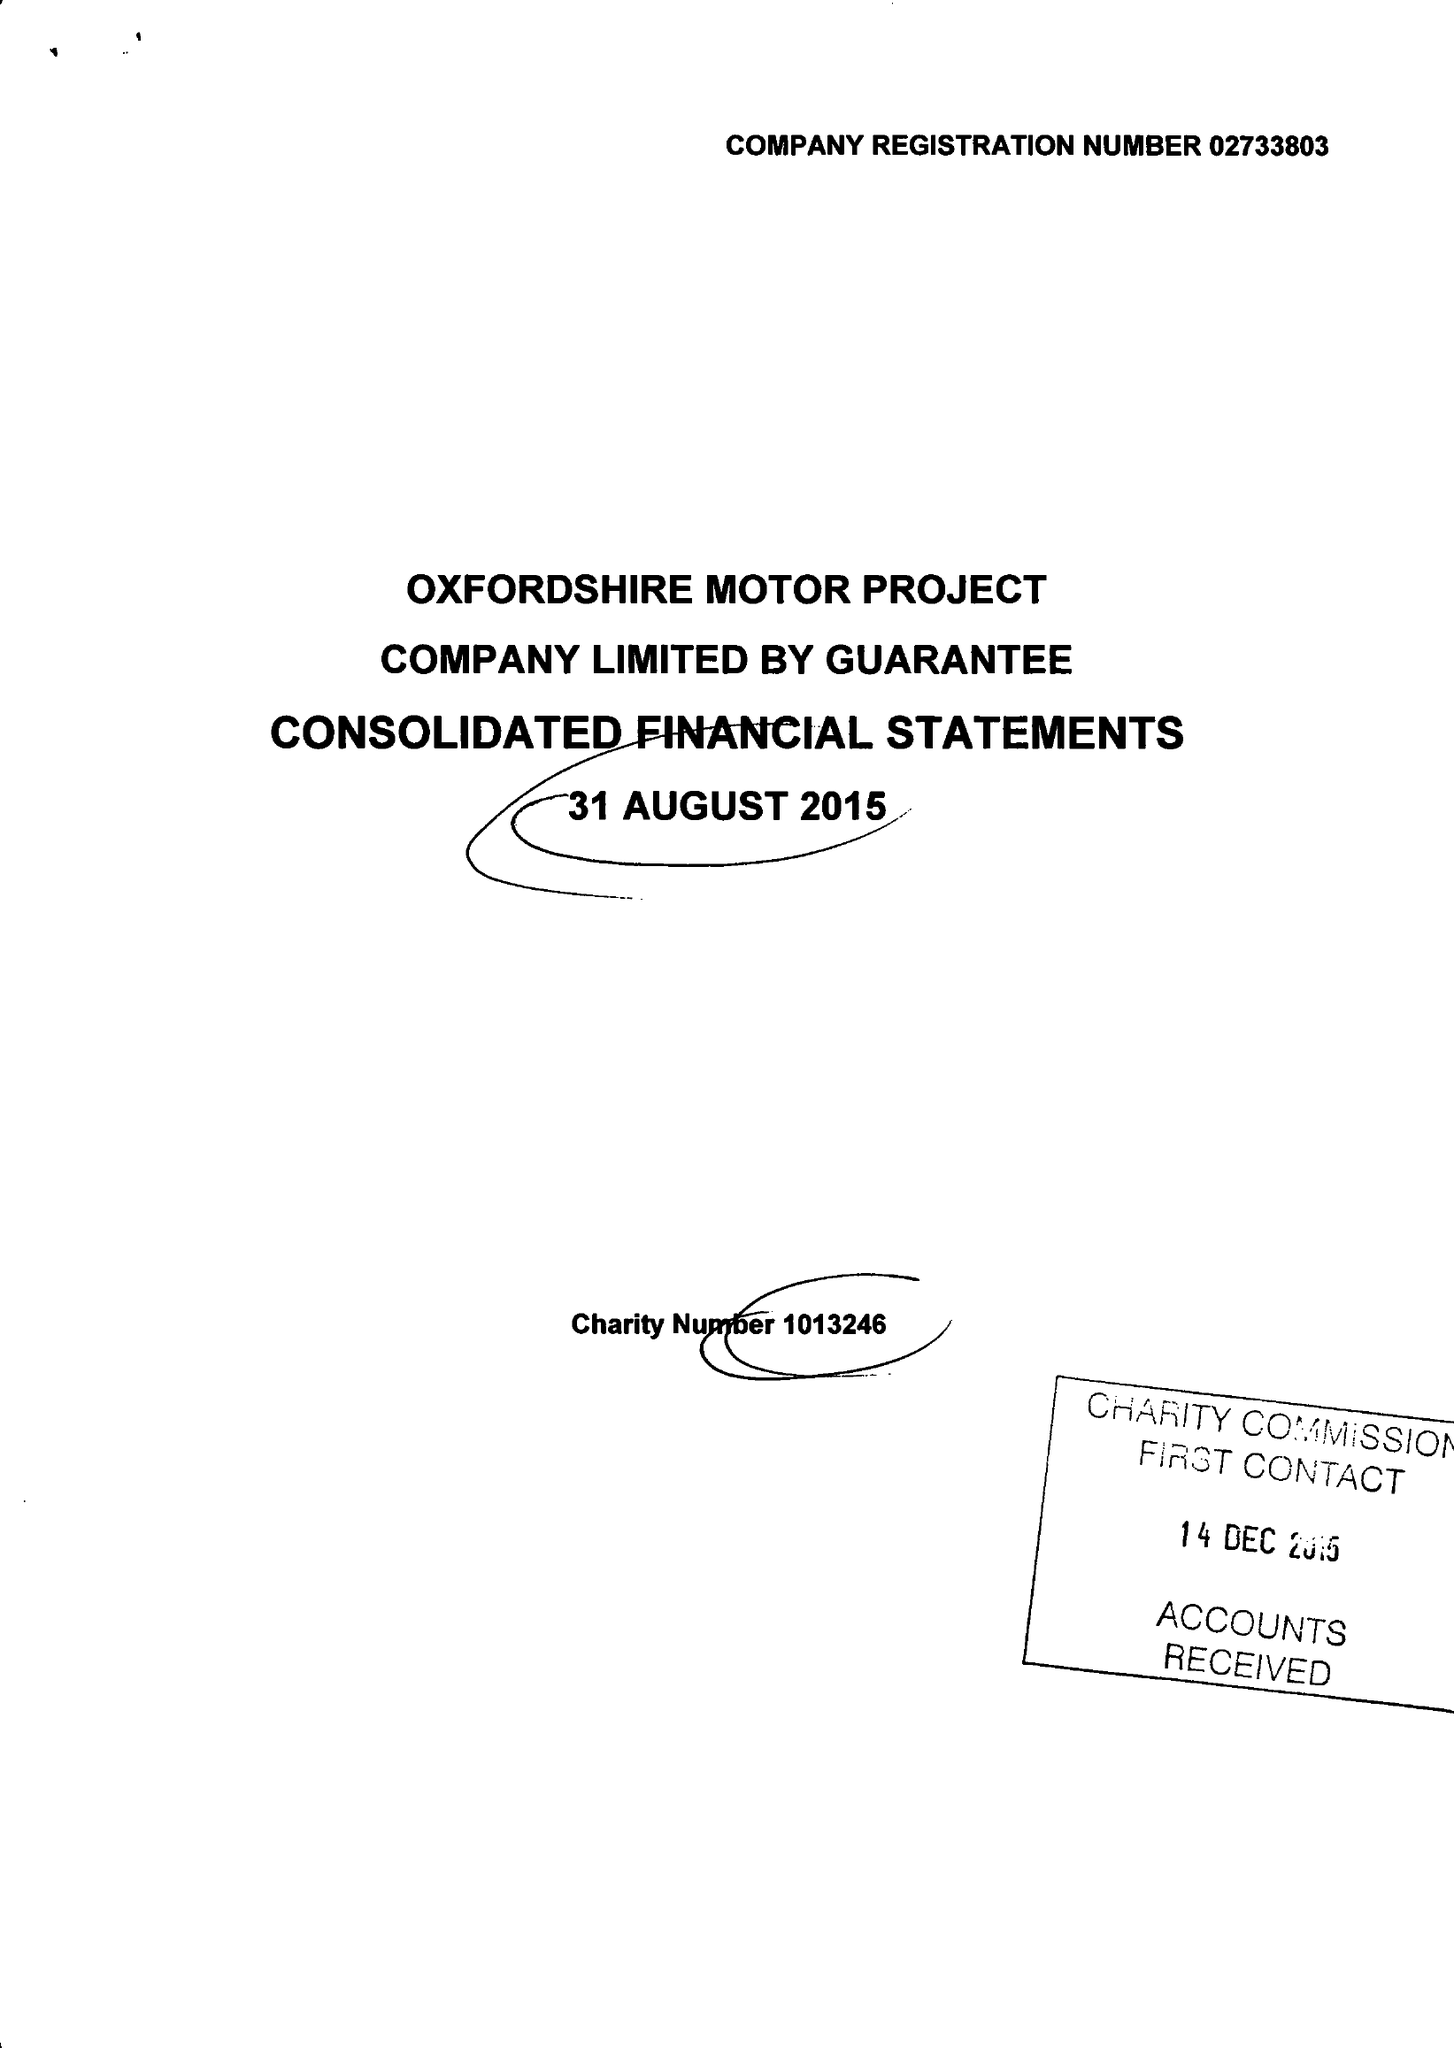What is the value for the address__street_line?
Answer the question using a single word or phrase. WOODSTOCK ROAD 